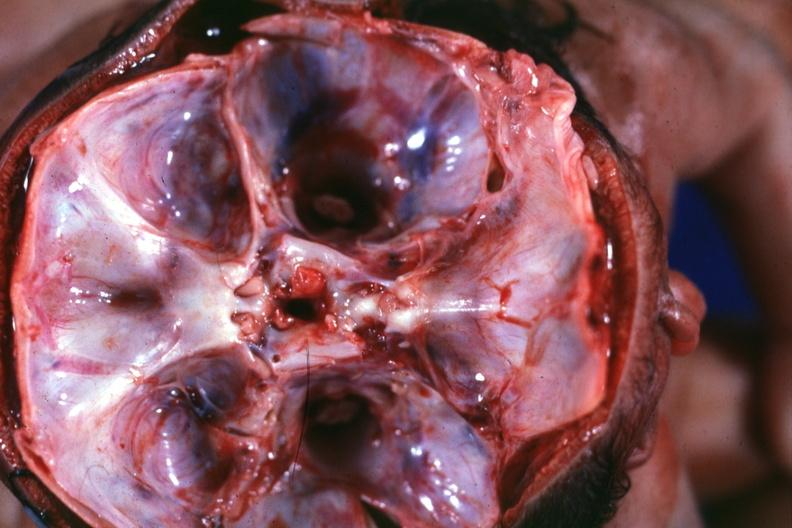s cephalothoracopagus janiceps present?
Answer the question using a single word or phrase. Yes 